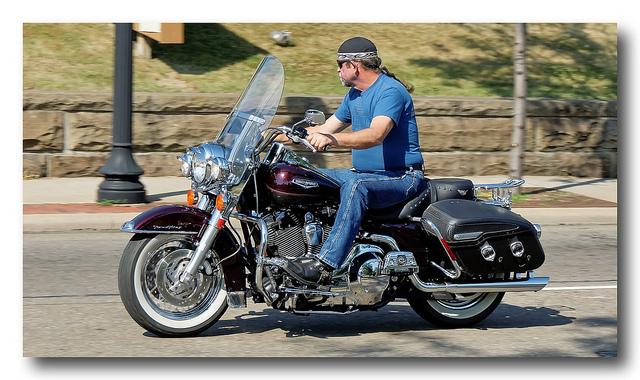What color is the bike?
Short answer required. Black. Are they driving through a forest?
Quick response, please. No. Does this man have on glasses?
Short answer required. Yes. What is on the pole behind the bike?
Give a very brief answer. Sign. What kind of material is being used to create a fence?
Write a very short answer. Stone. What color is the man's shirt?
Keep it brief. Blue. 